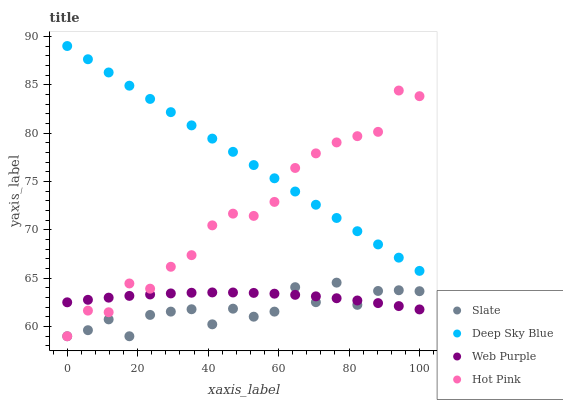Does Slate have the minimum area under the curve?
Answer yes or no. Yes. Does Deep Sky Blue have the maximum area under the curve?
Answer yes or no. Yes. Does Hot Pink have the minimum area under the curve?
Answer yes or no. No. Does Hot Pink have the maximum area under the curve?
Answer yes or no. No. Is Deep Sky Blue the smoothest?
Answer yes or no. Yes. Is Slate the roughest?
Answer yes or no. Yes. Is Hot Pink the smoothest?
Answer yes or no. No. Is Hot Pink the roughest?
Answer yes or no. No. Does Slate have the lowest value?
Answer yes or no. Yes. Does Web Purple have the lowest value?
Answer yes or no. No. Does Deep Sky Blue have the highest value?
Answer yes or no. Yes. Does Hot Pink have the highest value?
Answer yes or no. No. Is Web Purple less than Deep Sky Blue?
Answer yes or no. Yes. Is Deep Sky Blue greater than Slate?
Answer yes or no. Yes. Does Deep Sky Blue intersect Hot Pink?
Answer yes or no. Yes. Is Deep Sky Blue less than Hot Pink?
Answer yes or no. No. Is Deep Sky Blue greater than Hot Pink?
Answer yes or no. No. Does Web Purple intersect Deep Sky Blue?
Answer yes or no. No. 